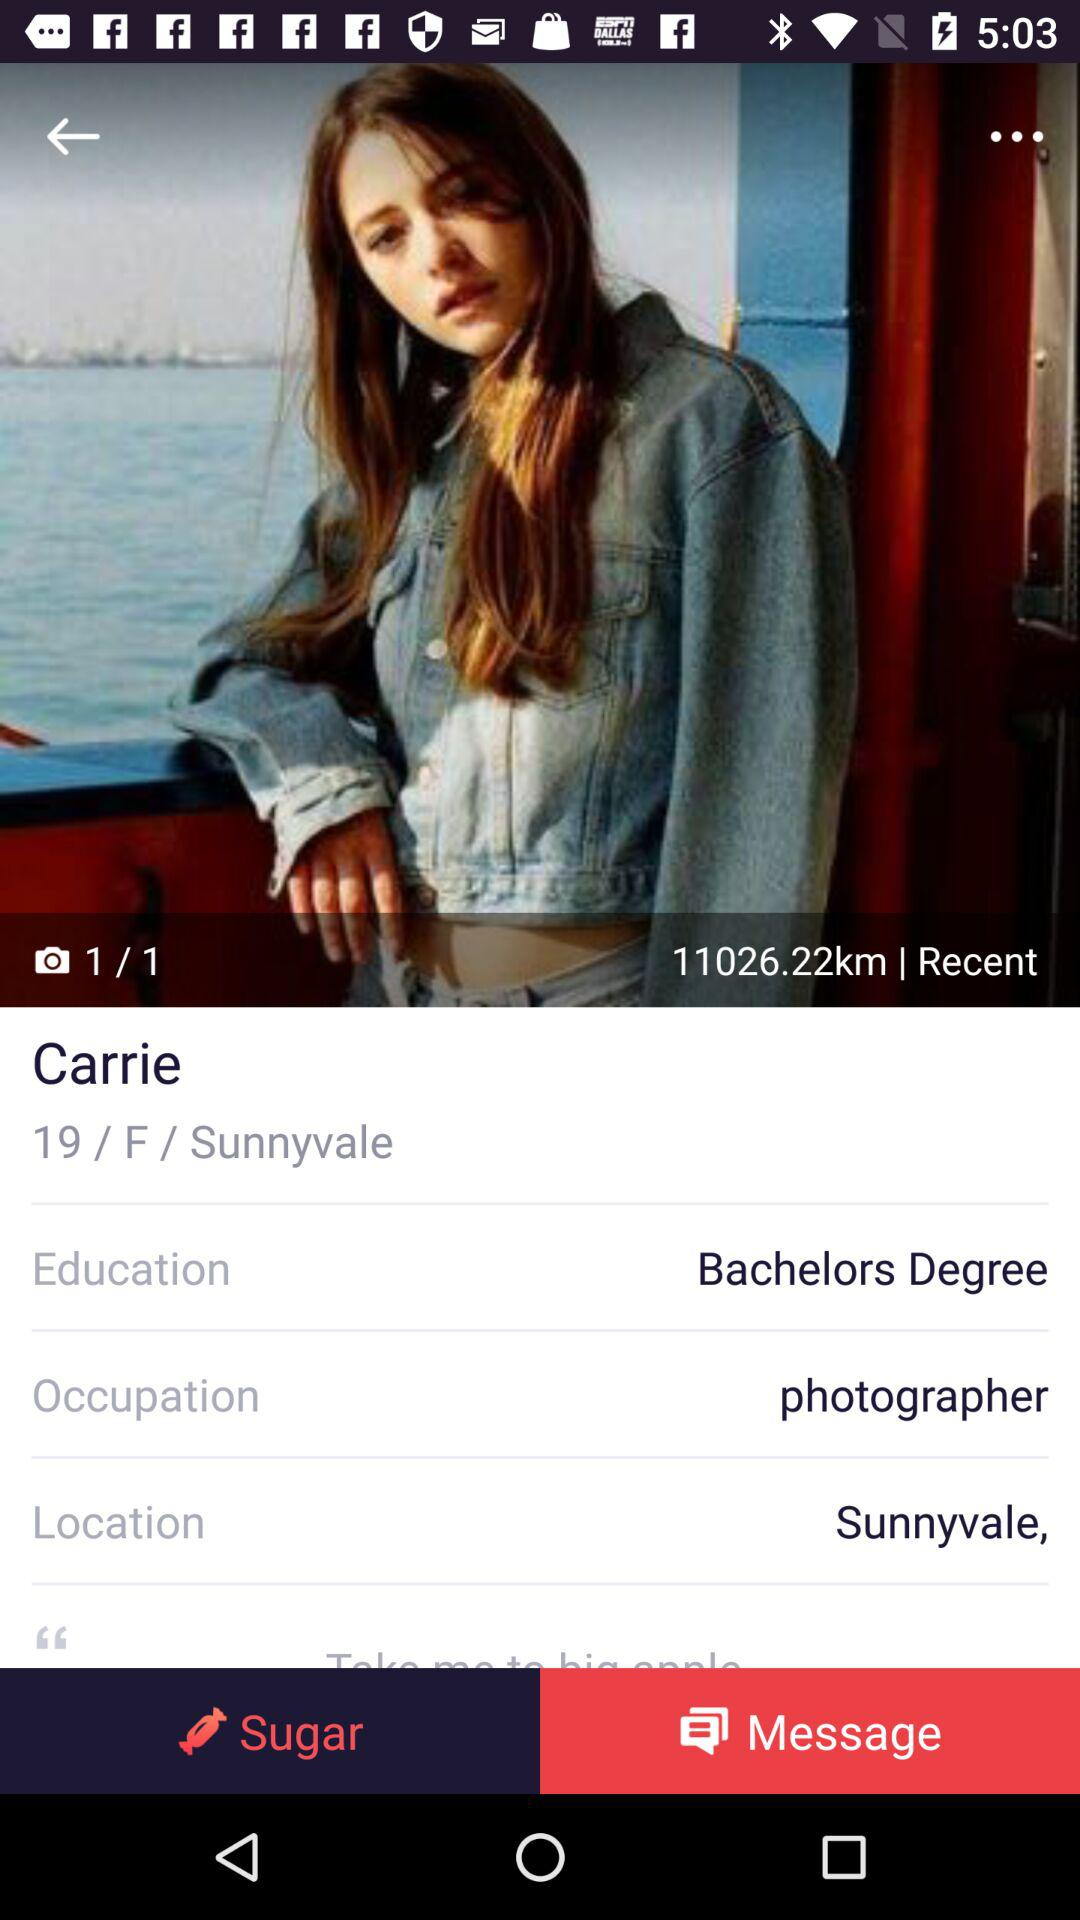What is the name of the girl? The name of the girl is Carrie. 